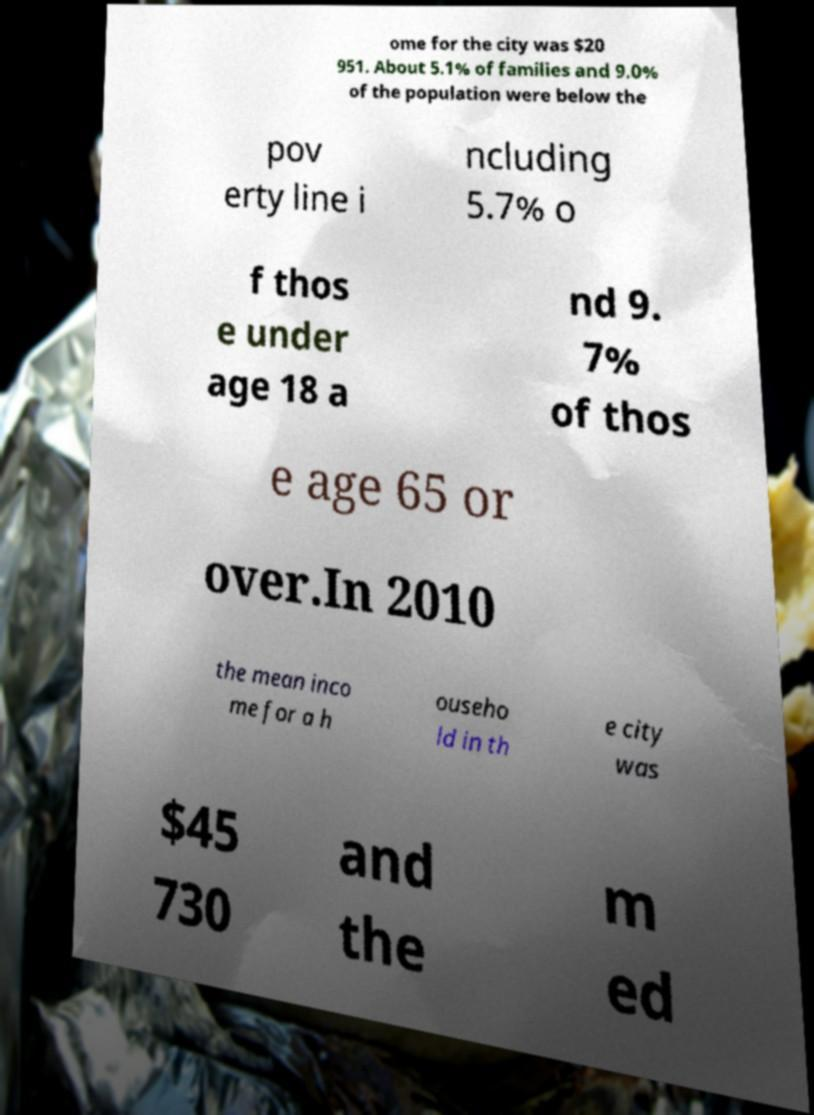There's text embedded in this image that I need extracted. Can you transcribe it verbatim? ome for the city was $20 951. About 5.1% of families and 9.0% of the population were below the pov erty line i ncluding 5.7% o f thos e under age 18 a nd 9. 7% of thos e age 65 or over.In 2010 the mean inco me for a h ouseho ld in th e city was $45 730 and the m ed 